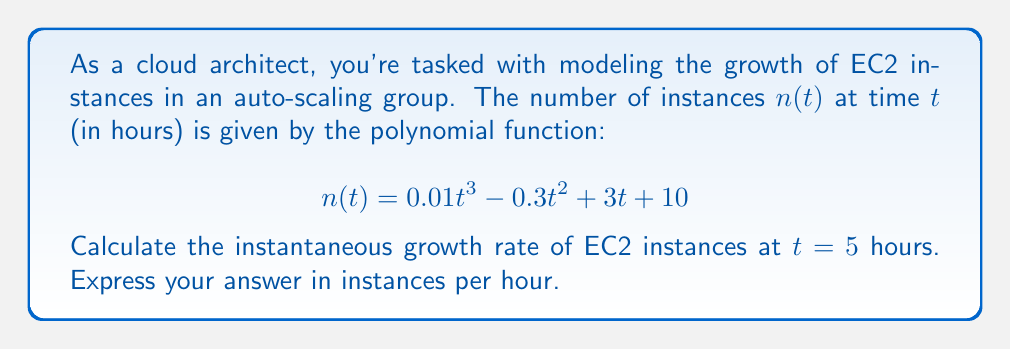Teach me how to tackle this problem. To solve this problem, we need to follow these steps:

1) The instantaneous growth rate at any point is given by the derivative of the function at that point.

2) Let's first find the derivative of $n(t)$:
   $$n'(t) = \frac{d}{dt}(0.01t^3 - 0.3t^2 + 3t + 10)$$
   $$n'(t) = 0.03t^2 - 0.6t + 3$$

3) Now, we need to evaluate this derivative at $t = 5$:
   $$n'(5) = 0.03(5^2) - 0.6(5) + 3$$
   $$n'(5) = 0.03(25) - 3 + 3$$
   $$n'(5) = 0.75 - 3 + 3$$
   $$n'(5) = 0.75$$

4) The result, 0.75, represents the instantaneous growth rate at $t = 5$ hours, measured in instances per hour.

This means that at the 5-hour mark, the number of EC2 instances is increasing at a rate of 0.75 instances per hour.
Answer: 0.75 instances per hour 